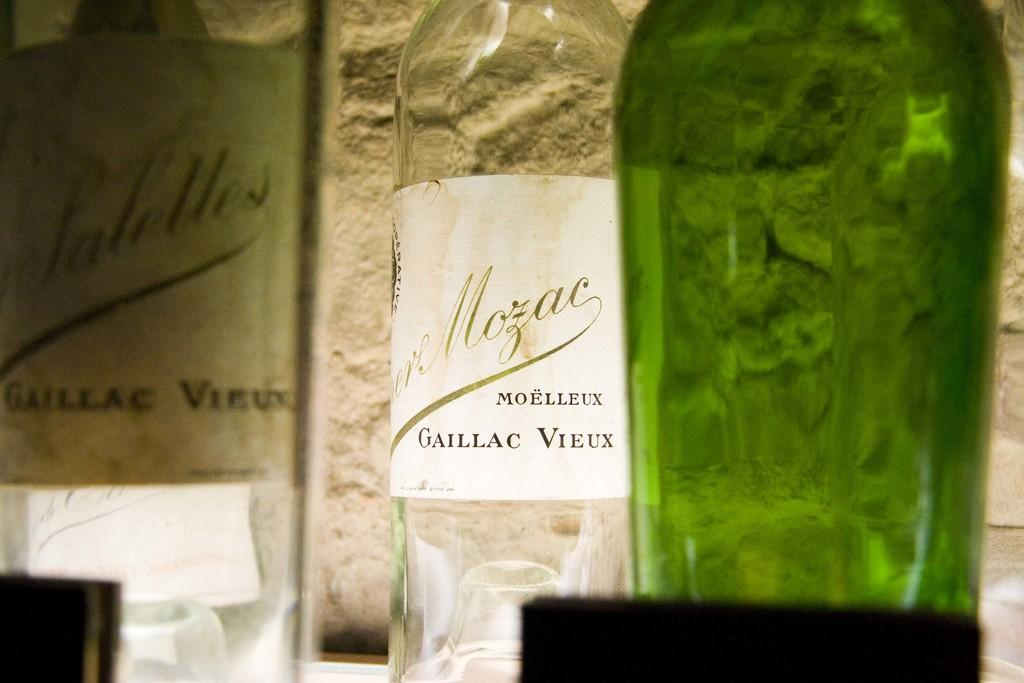How many bottles can be seen in the image? There are three bottles in the image. What is visible in the background of the image? There is a wall in the background of the image. What type of hook can be seen hanging from the wall in the image? There is no hook visible in the image; only the three bottles and the wall are present. How many bells are attached to the bottles in the image? There are no bells attached to the bottles in the image. 